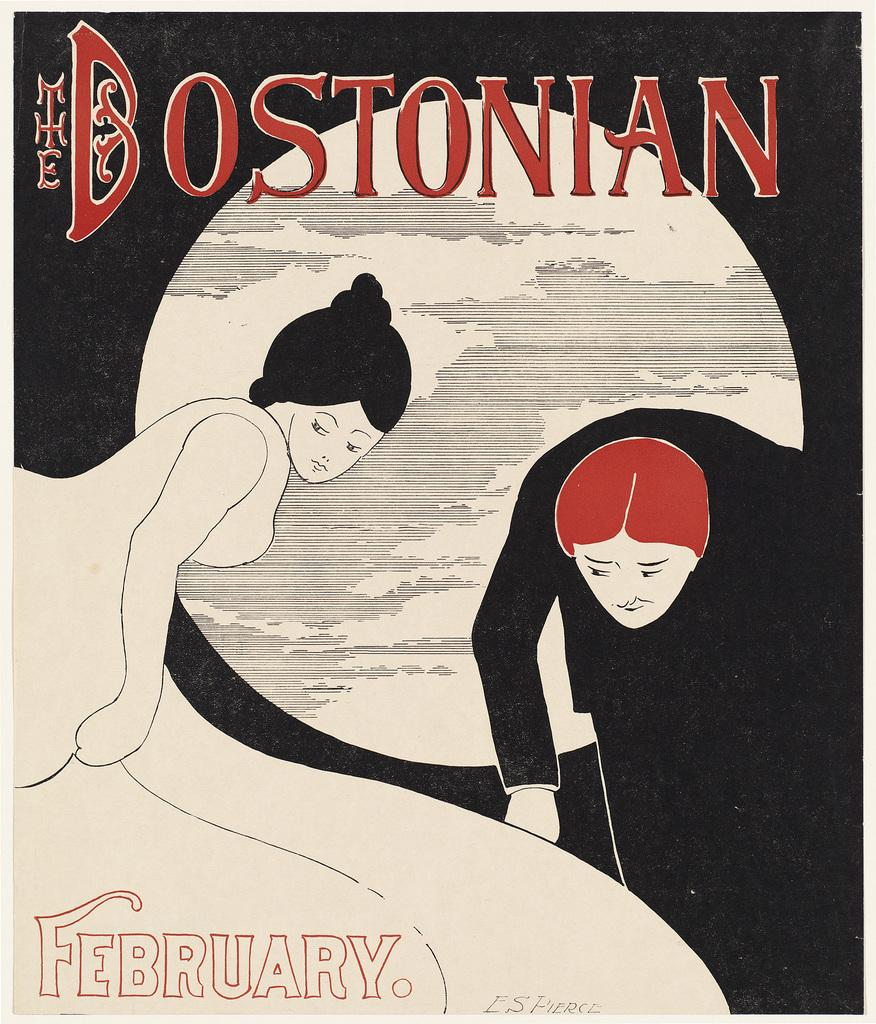What is featured on the poster in the image? The poster has paintings of persons and the moon. What else can be seen on the poster besides the images? There is text on the poster. What is the color scheme of the poster's background? The background of the poster is black and white. How many quince are depicted in the poster? There are no quince depicted in the poster; it features paintings of persons and the moon. What type of bubble is shown in the poster? There is no bubble present in the poster. 